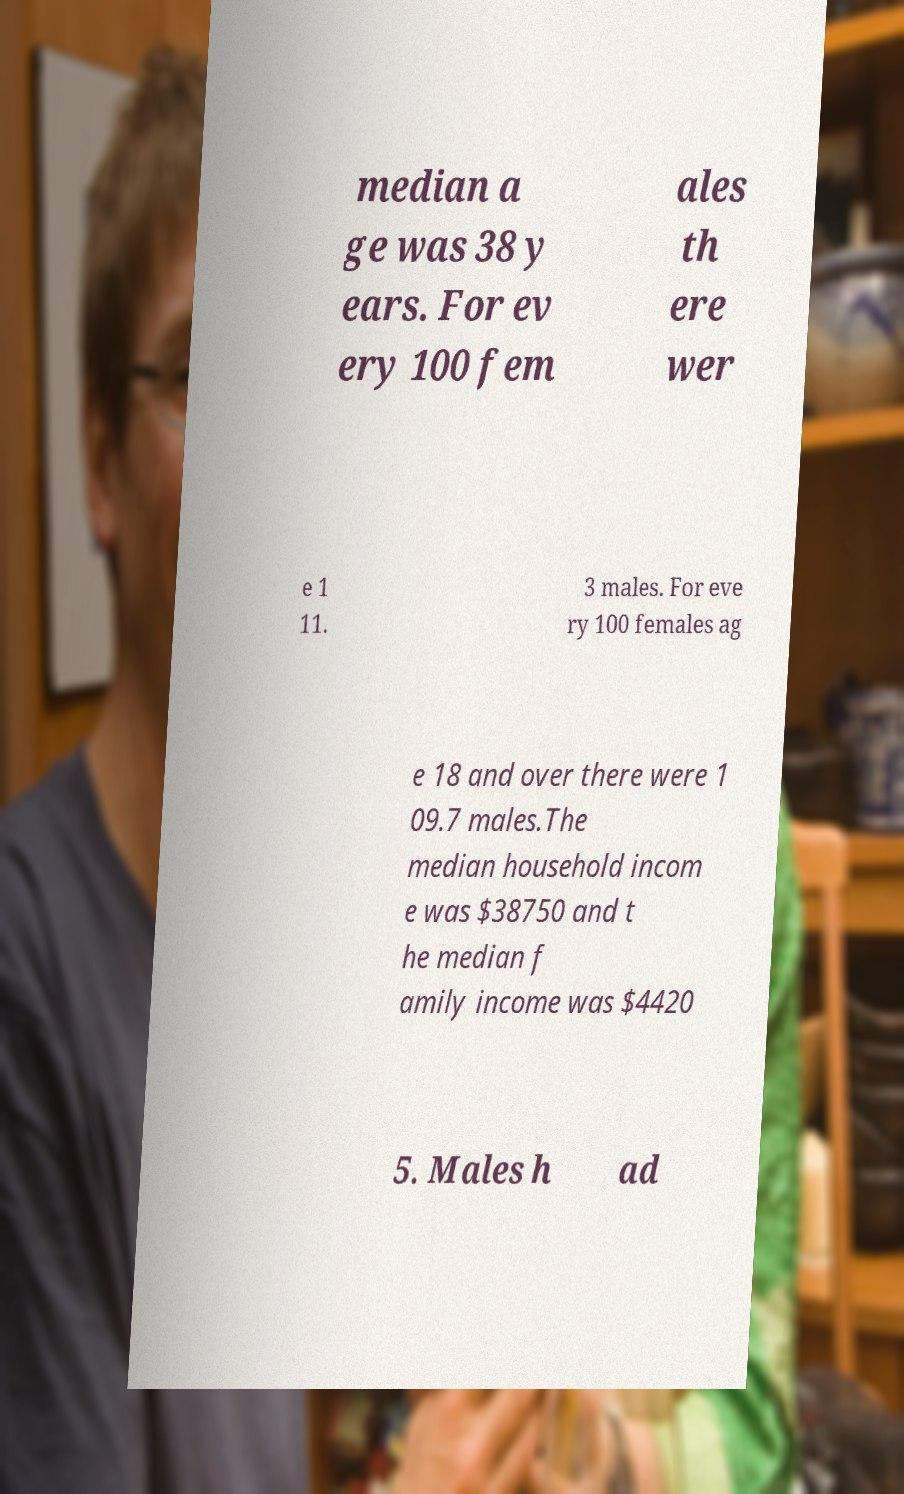Could you assist in decoding the text presented in this image and type it out clearly? median a ge was 38 y ears. For ev ery 100 fem ales th ere wer e 1 11. 3 males. For eve ry 100 females ag e 18 and over there were 1 09.7 males.The median household incom e was $38750 and t he median f amily income was $4420 5. Males h ad 